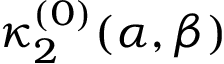<formula> <loc_0><loc_0><loc_500><loc_500>\kappa _ { 2 } ^ { ( 0 ) } ( \alpha , \beta )</formula> 